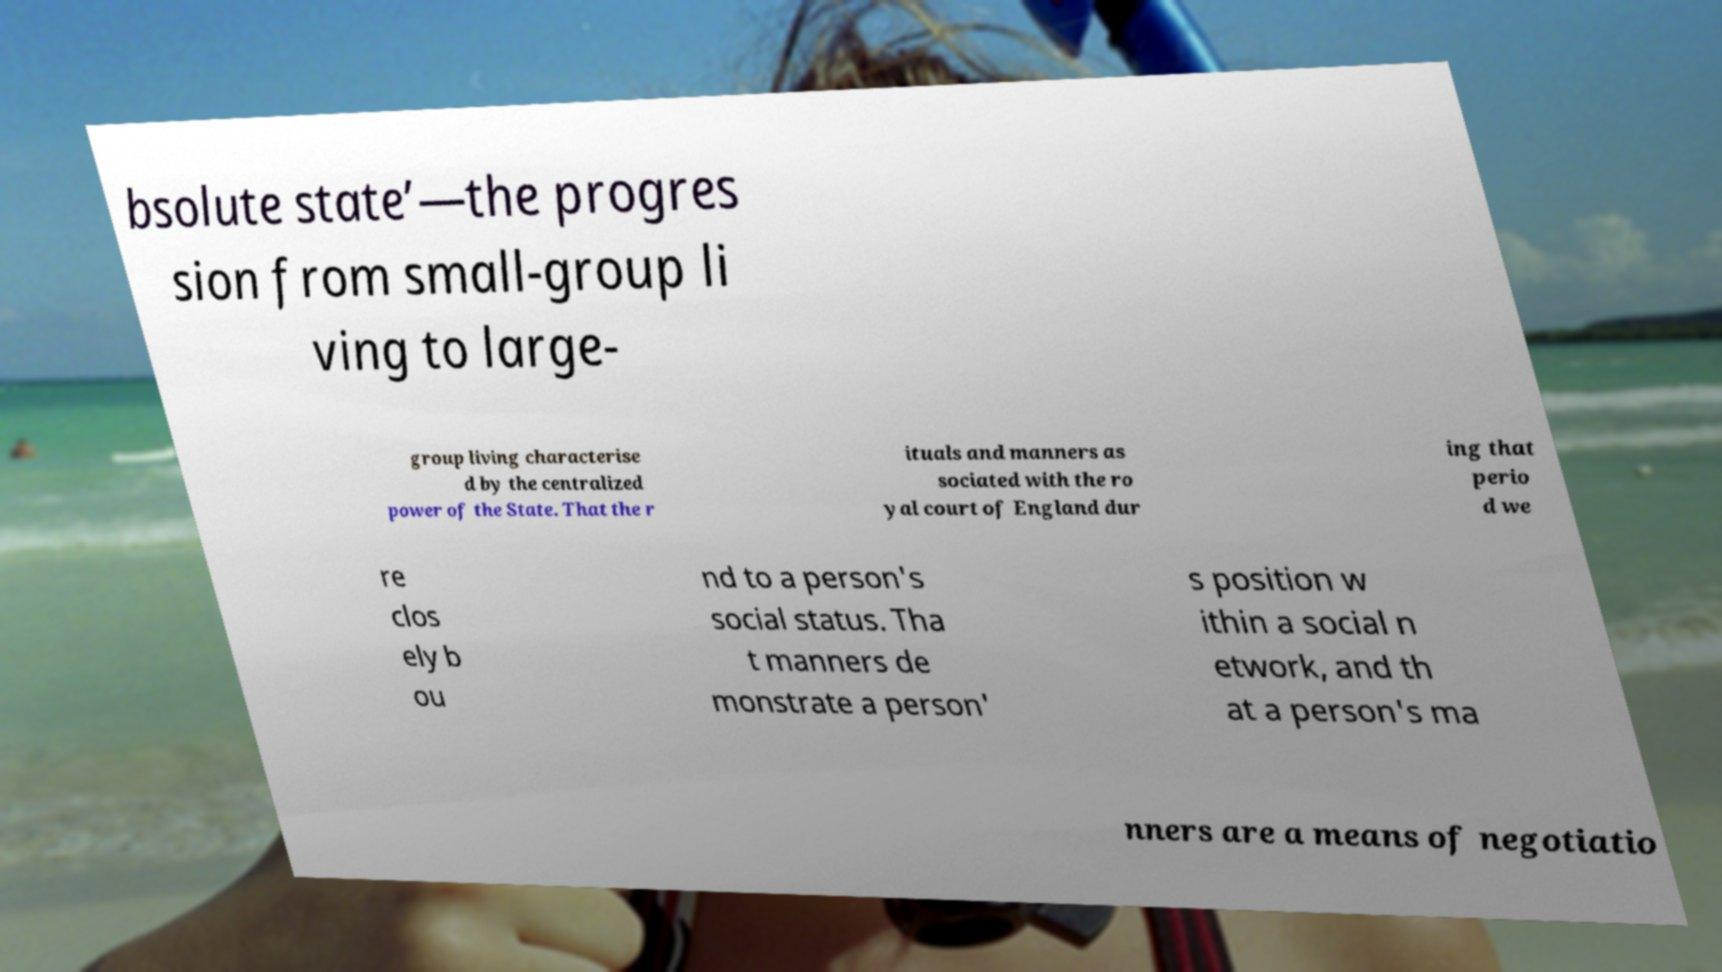I need the written content from this picture converted into text. Can you do that? bsolute state’—the progres sion from small-group li ving to large- group living characterise d by the centralized power of the State. That the r ituals and manners as sociated with the ro yal court of England dur ing that perio d we re clos ely b ou nd to a person's social status. Tha t manners de monstrate a person' s position w ithin a social n etwork, and th at a person's ma nners are a means of negotiatio 